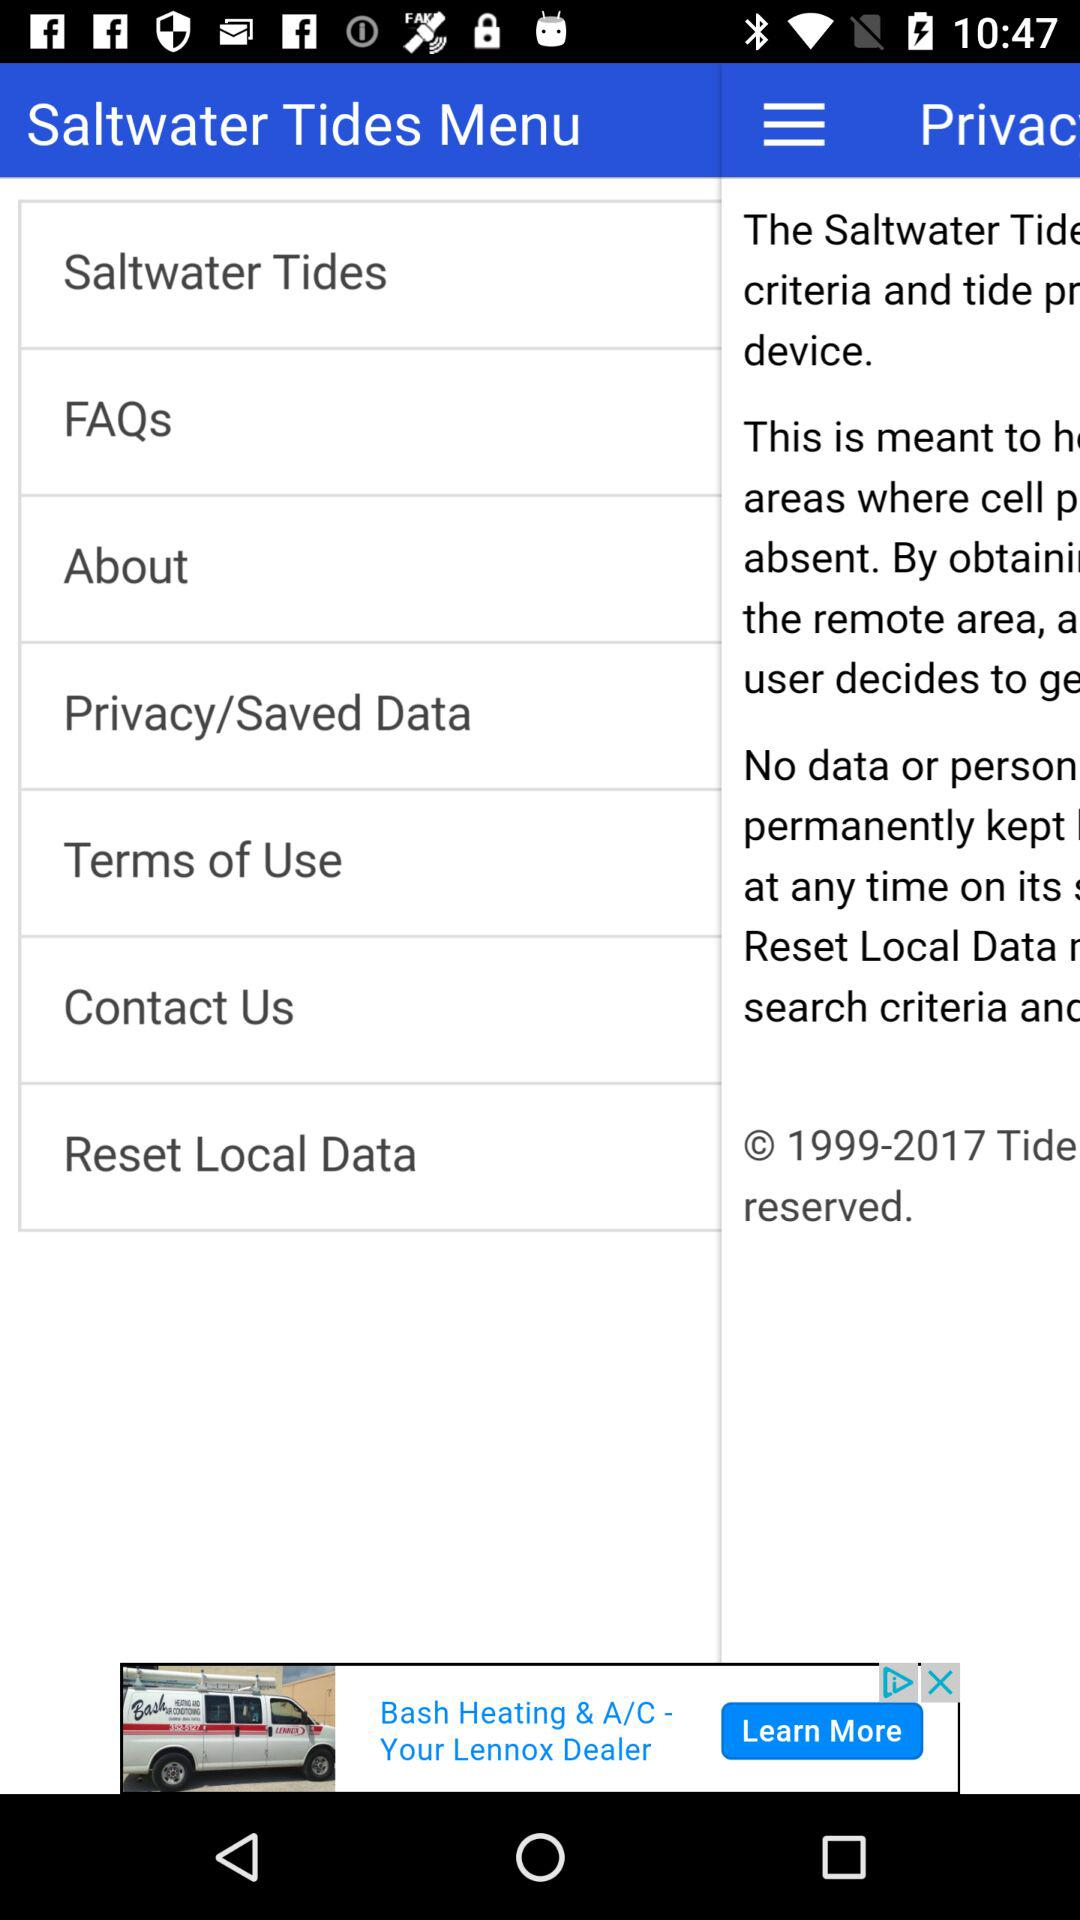What is the application name? The application name is "Saltwater Tides Menu". 